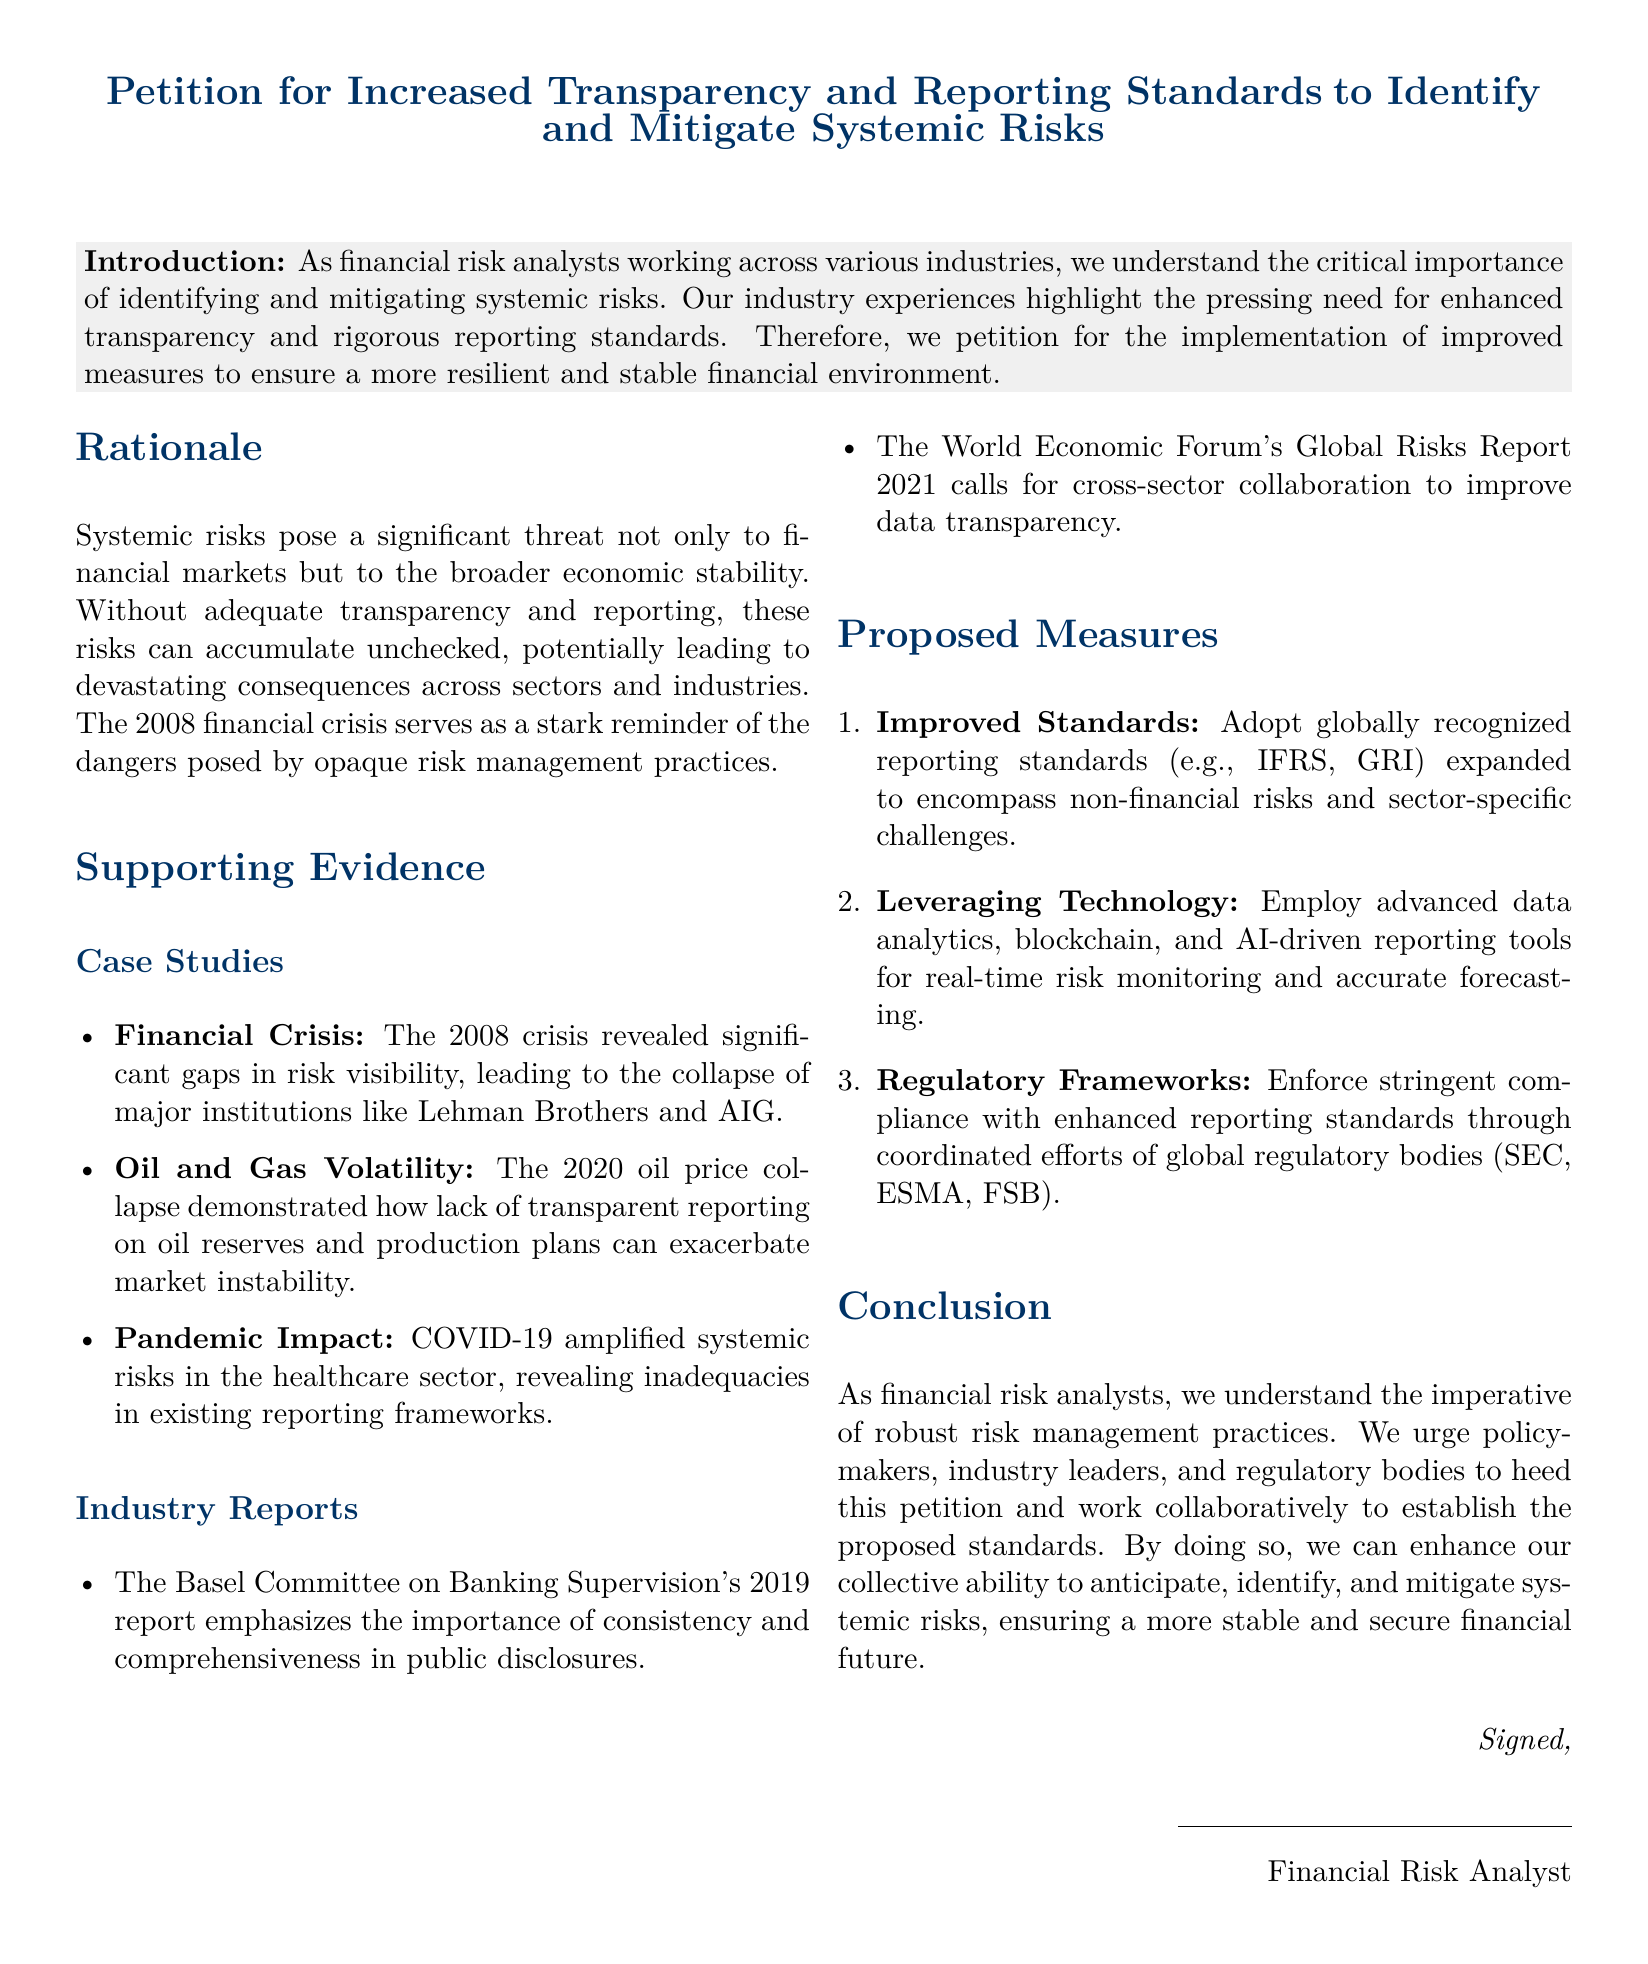What is the main purpose of the petition? The main purpose of the petition is to request enhanced transparency and rigorous reporting standards to identify and mitigate systemic risks.
Answer: Increased transparency and reporting standards What year did the financial crisis mentioned occur? The document refers to the financial crisis that happened in 2008.
Answer: 2008 What industry aspect does the Basel Committee report emphasize? The Basel Committee on Banking Supervision's report emphasizes the importance of consistency and comprehensiveness in public disclosures.
Answer: Consistency and comprehensiveness Name one technology proposed for risk monitoring. The document suggests employing advanced data analytics, blockchain, and AI-driven reporting tools.
Answer: AI-driven reporting tools How many case studies are cited in the supporting evidence section? The document lists three case studies under supporting evidence.
Answer: Three What is one of the proposed regulatory measures? The proposed measures includes enforcing stringent compliance with enhanced reporting standards.
Answer: Stringent compliance What does COVID-19 highlight in terms of risks? COVID-19 amplified systemic risks in the healthcare sector, revealing inadequacies in existing reporting frameworks.
Answer: Inadequacies in existing reporting frameworks Who should collaborate to establish the proposed standards? The document urges policymakers, industry leaders, and regulatory bodies to work collaboratively.
Answer: Policymakers, industry leaders, and regulatory bodies 